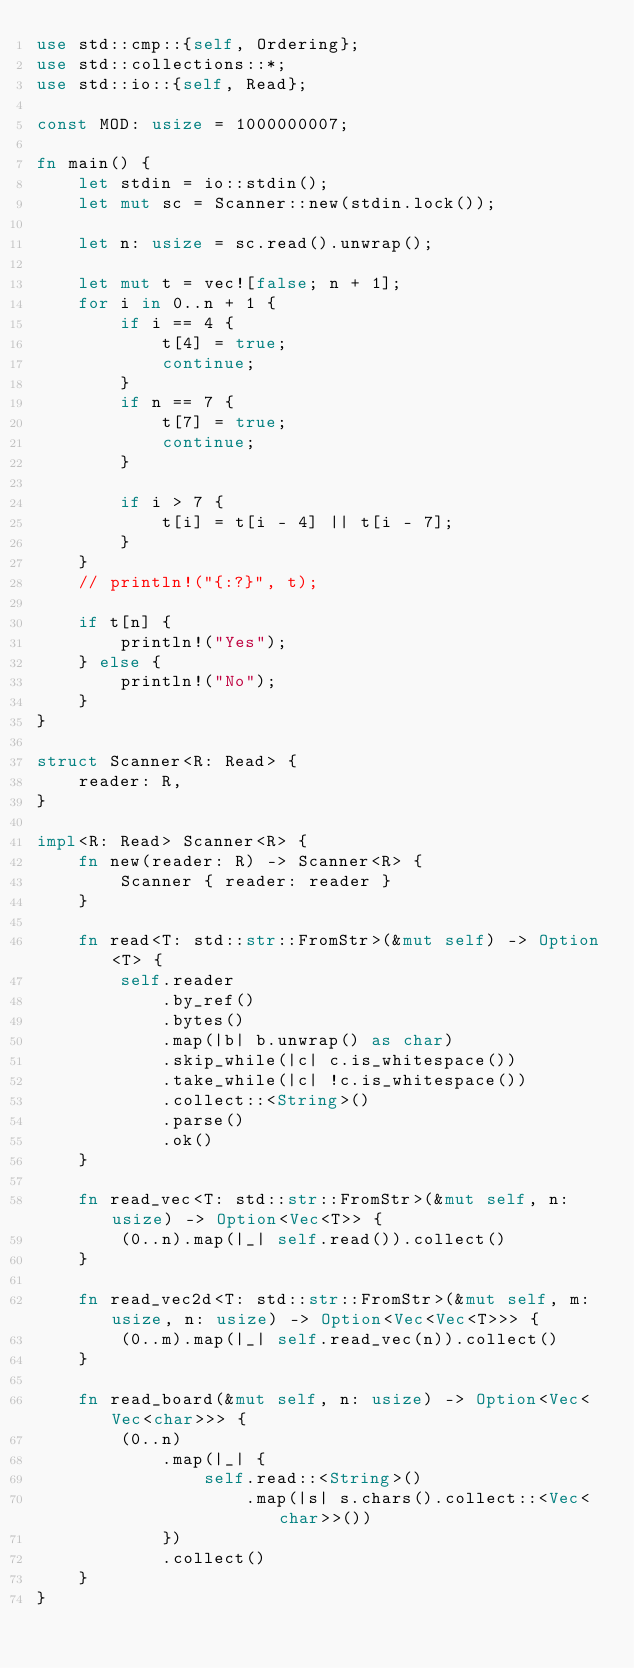<code> <loc_0><loc_0><loc_500><loc_500><_Rust_>use std::cmp::{self, Ordering};
use std::collections::*;
use std::io::{self, Read};

const MOD: usize = 1000000007;

fn main() {
    let stdin = io::stdin();
    let mut sc = Scanner::new(stdin.lock());

    let n: usize = sc.read().unwrap();

    let mut t = vec![false; n + 1];
    for i in 0..n + 1 {
        if i == 4 {
            t[4] = true;
            continue;
        }
        if n == 7 {
            t[7] = true;
            continue;
        }

        if i > 7 {
            t[i] = t[i - 4] || t[i - 7];
        }
    }
    // println!("{:?}", t);

    if t[n] {
        println!("Yes");
    } else {
        println!("No");
    }
}

struct Scanner<R: Read> {
    reader: R,
}

impl<R: Read> Scanner<R> {
    fn new(reader: R) -> Scanner<R> {
        Scanner { reader: reader }
    }

    fn read<T: std::str::FromStr>(&mut self) -> Option<T> {
        self.reader
            .by_ref()
            .bytes()
            .map(|b| b.unwrap() as char)
            .skip_while(|c| c.is_whitespace())
            .take_while(|c| !c.is_whitespace())
            .collect::<String>()
            .parse()
            .ok()
    }

    fn read_vec<T: std::str::FromStr>(&mut self, n: usize) -> Option<Vec<T>> {
        (0..n).map(|_| self.read()).collect()
    }

    fn read_vec2d<T: std::str::FromStr>(&mut self, m: usize, n: usize) -> Option<Vec<Vec<T>>> {
        (0..m).map(|_| self.read_vec(n)).collect()
    }

    fn read_board(&mut self, n: usize) -> Option<Vec<Vec<char>>> {
        (0..n)
            .map(|_| {
                self.read::<String>()
                    .map(|s| s.chars().collect::<Vec<char>>())
            })
            .collect()
    }
}
</code> 